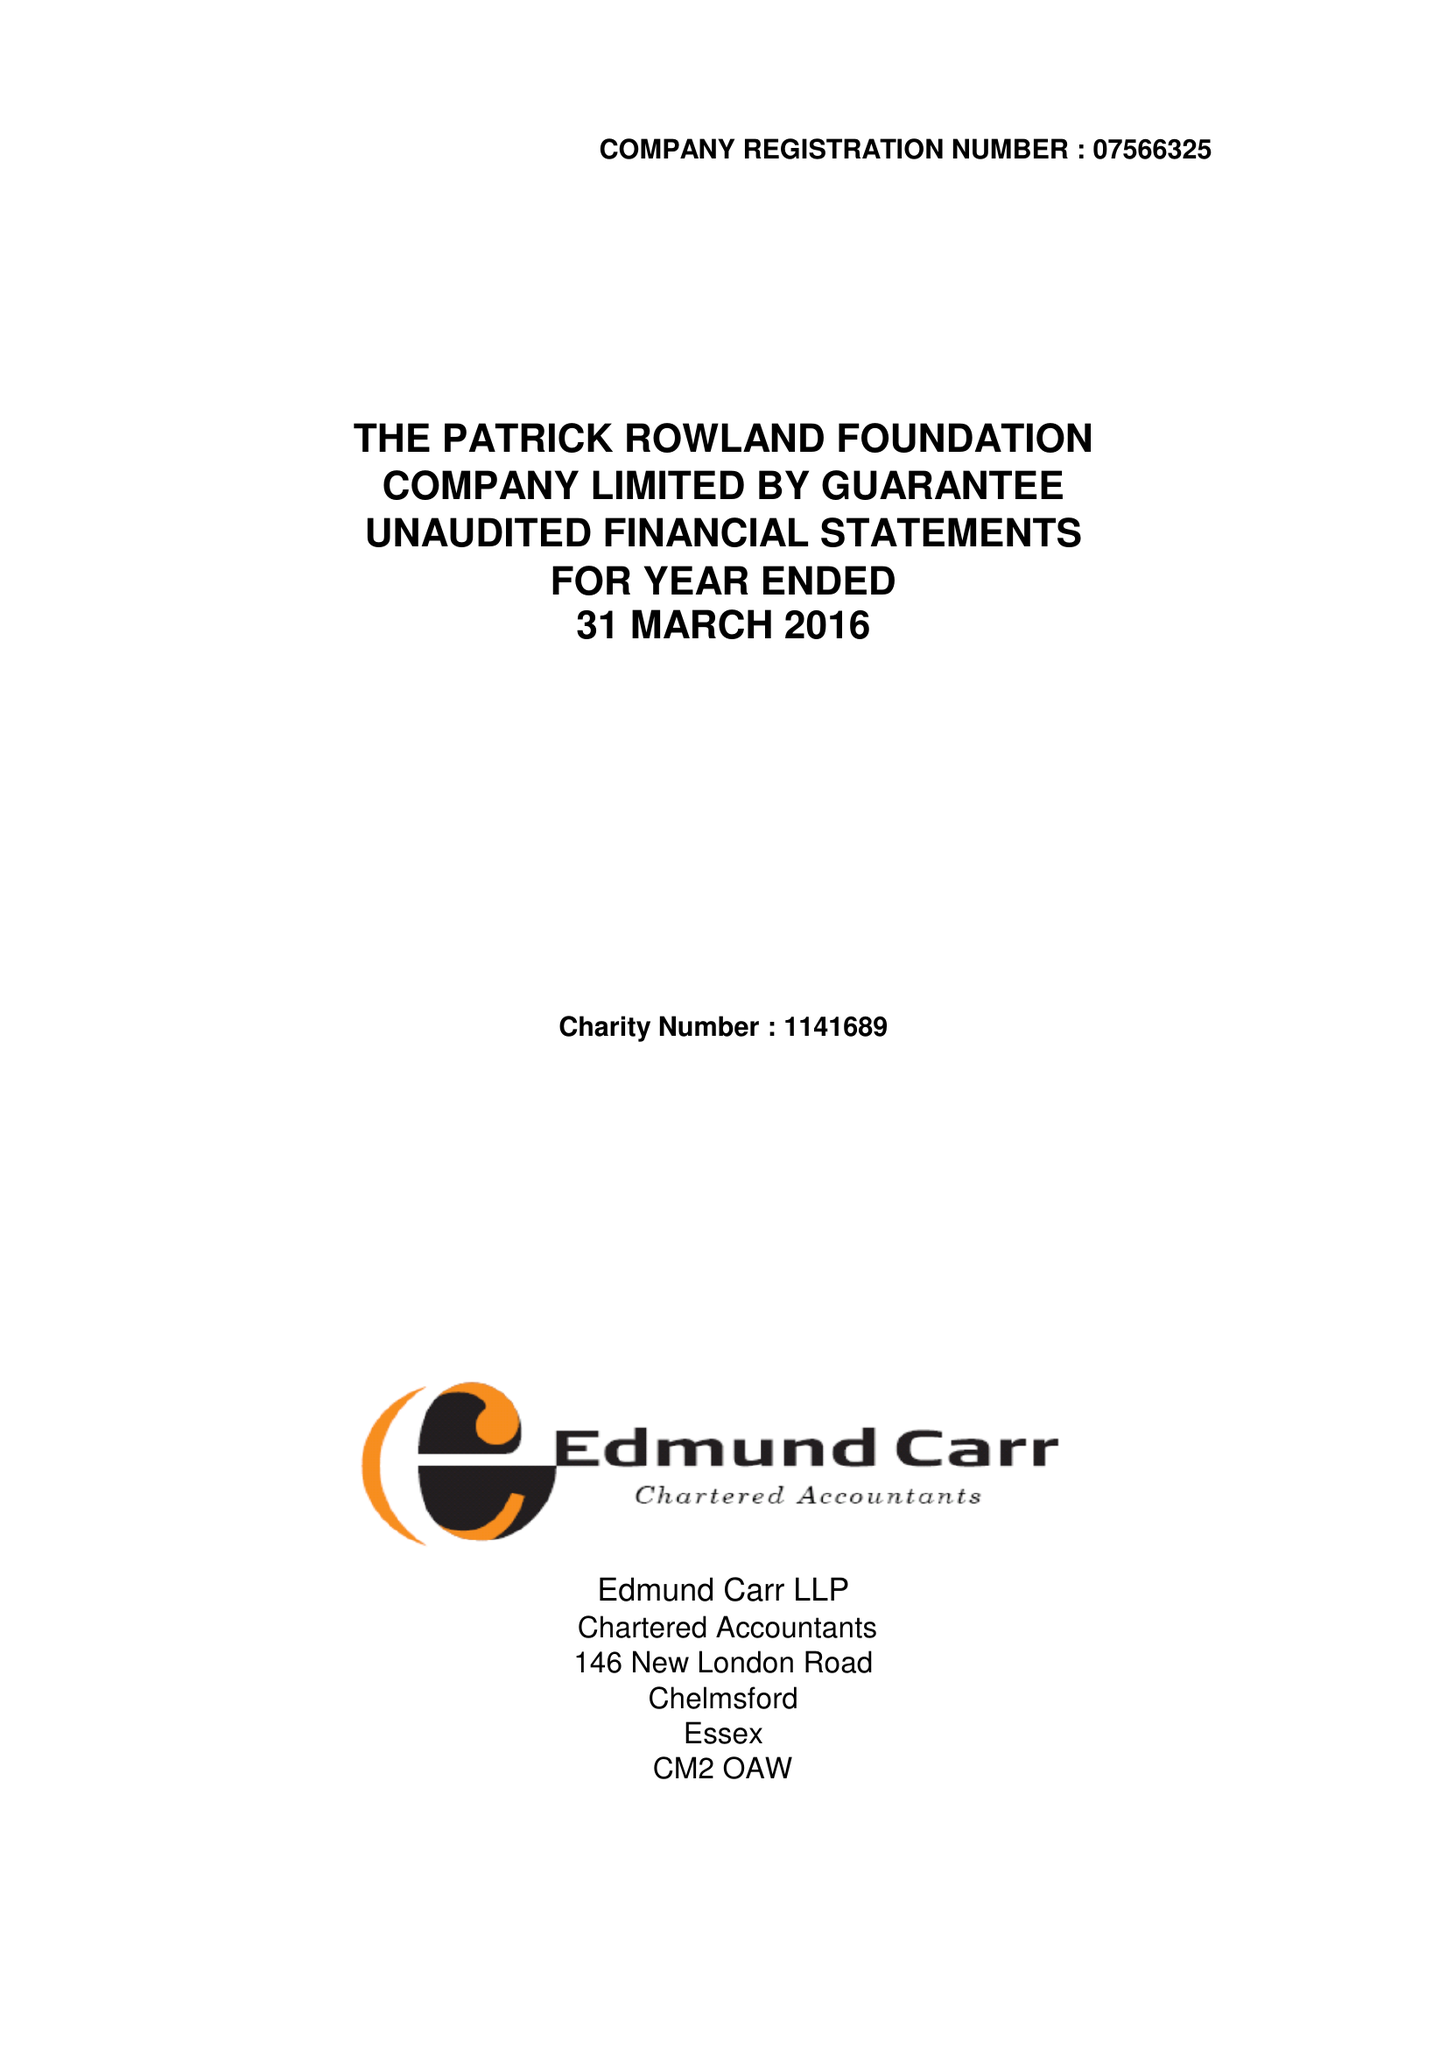What is the value for the income_annually_in_british_pounds?
Answer the question using a single word or phrase. 64912.00 